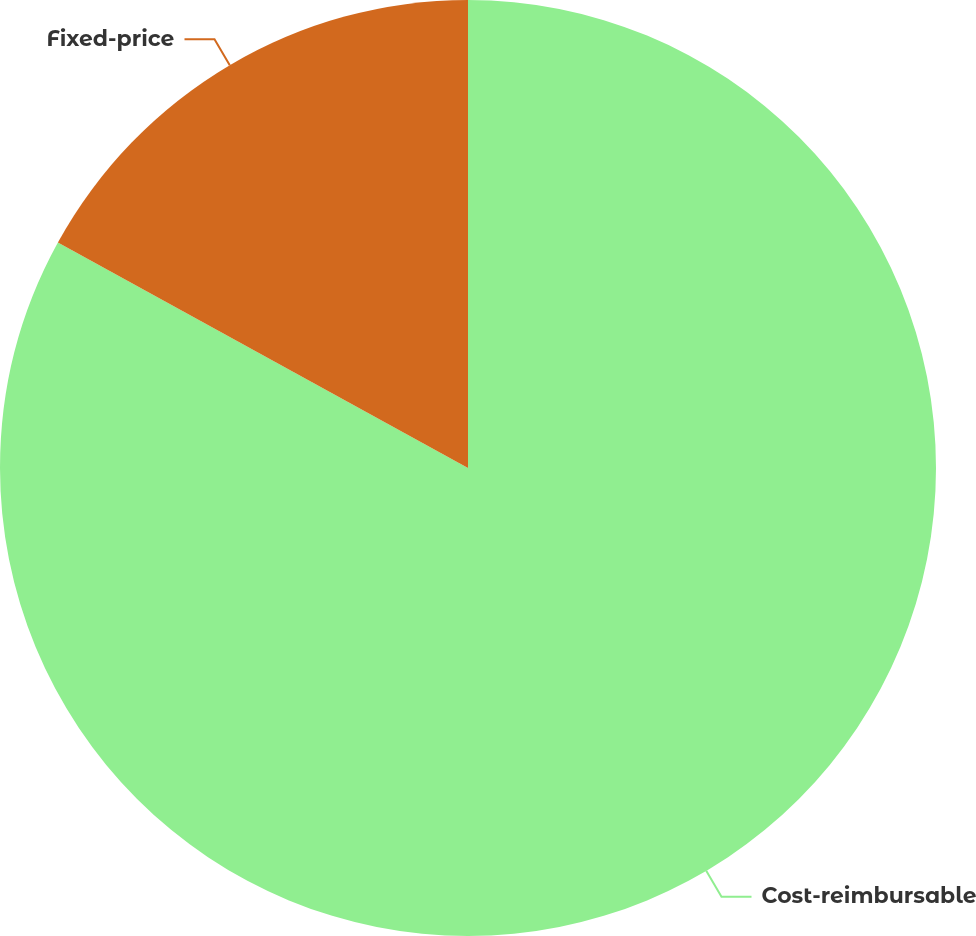Convert chart. <chart><loc_0><loc_0><loc_500><loc_500><pie_chart><fcel>Cost-reimbursable<fcel>Fixed-price<nl><fcel>83.0%<fcel>17.0%<nl></chart> 